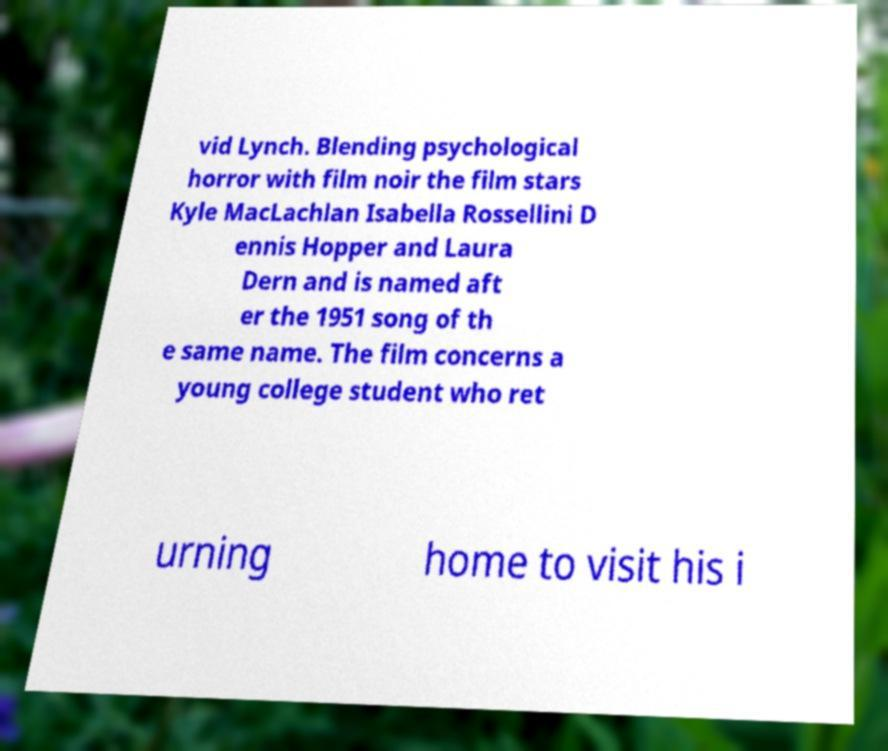Can you accurately transcribe the text from the provided image for me? vid Lynch. Blending psychological horror with film noir the film stars Kyle MacLachlan Isabella Rossellini D ennis Hopper and Laura Dern and is named aft er the 1951 song of th e same name. The film concerns a young college student who ret urning home to visit his i 